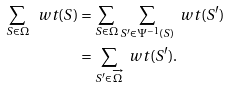<formula> <loc_0><loc_0><loc_500><loc_500>\sum _ { S \in \Omega } \ w t ( S ) & = \sum _ { S \in \Omega } \sum _ { S ^ { \prime } \in \Psi ^ { - 1 } ( S ) } \ w t ( S ^ { \prime } ) \\ & = \sum _ { S ^ { \prime } \in \overrightarrow { \Omega } } \ w t ( S ^ { \prime } ) .</formula> 